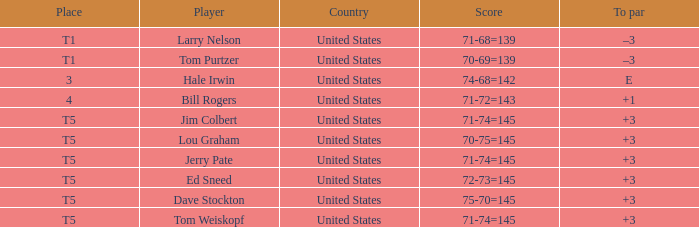Can you identify the player with a score of 70-75=145? Lou Graham. 